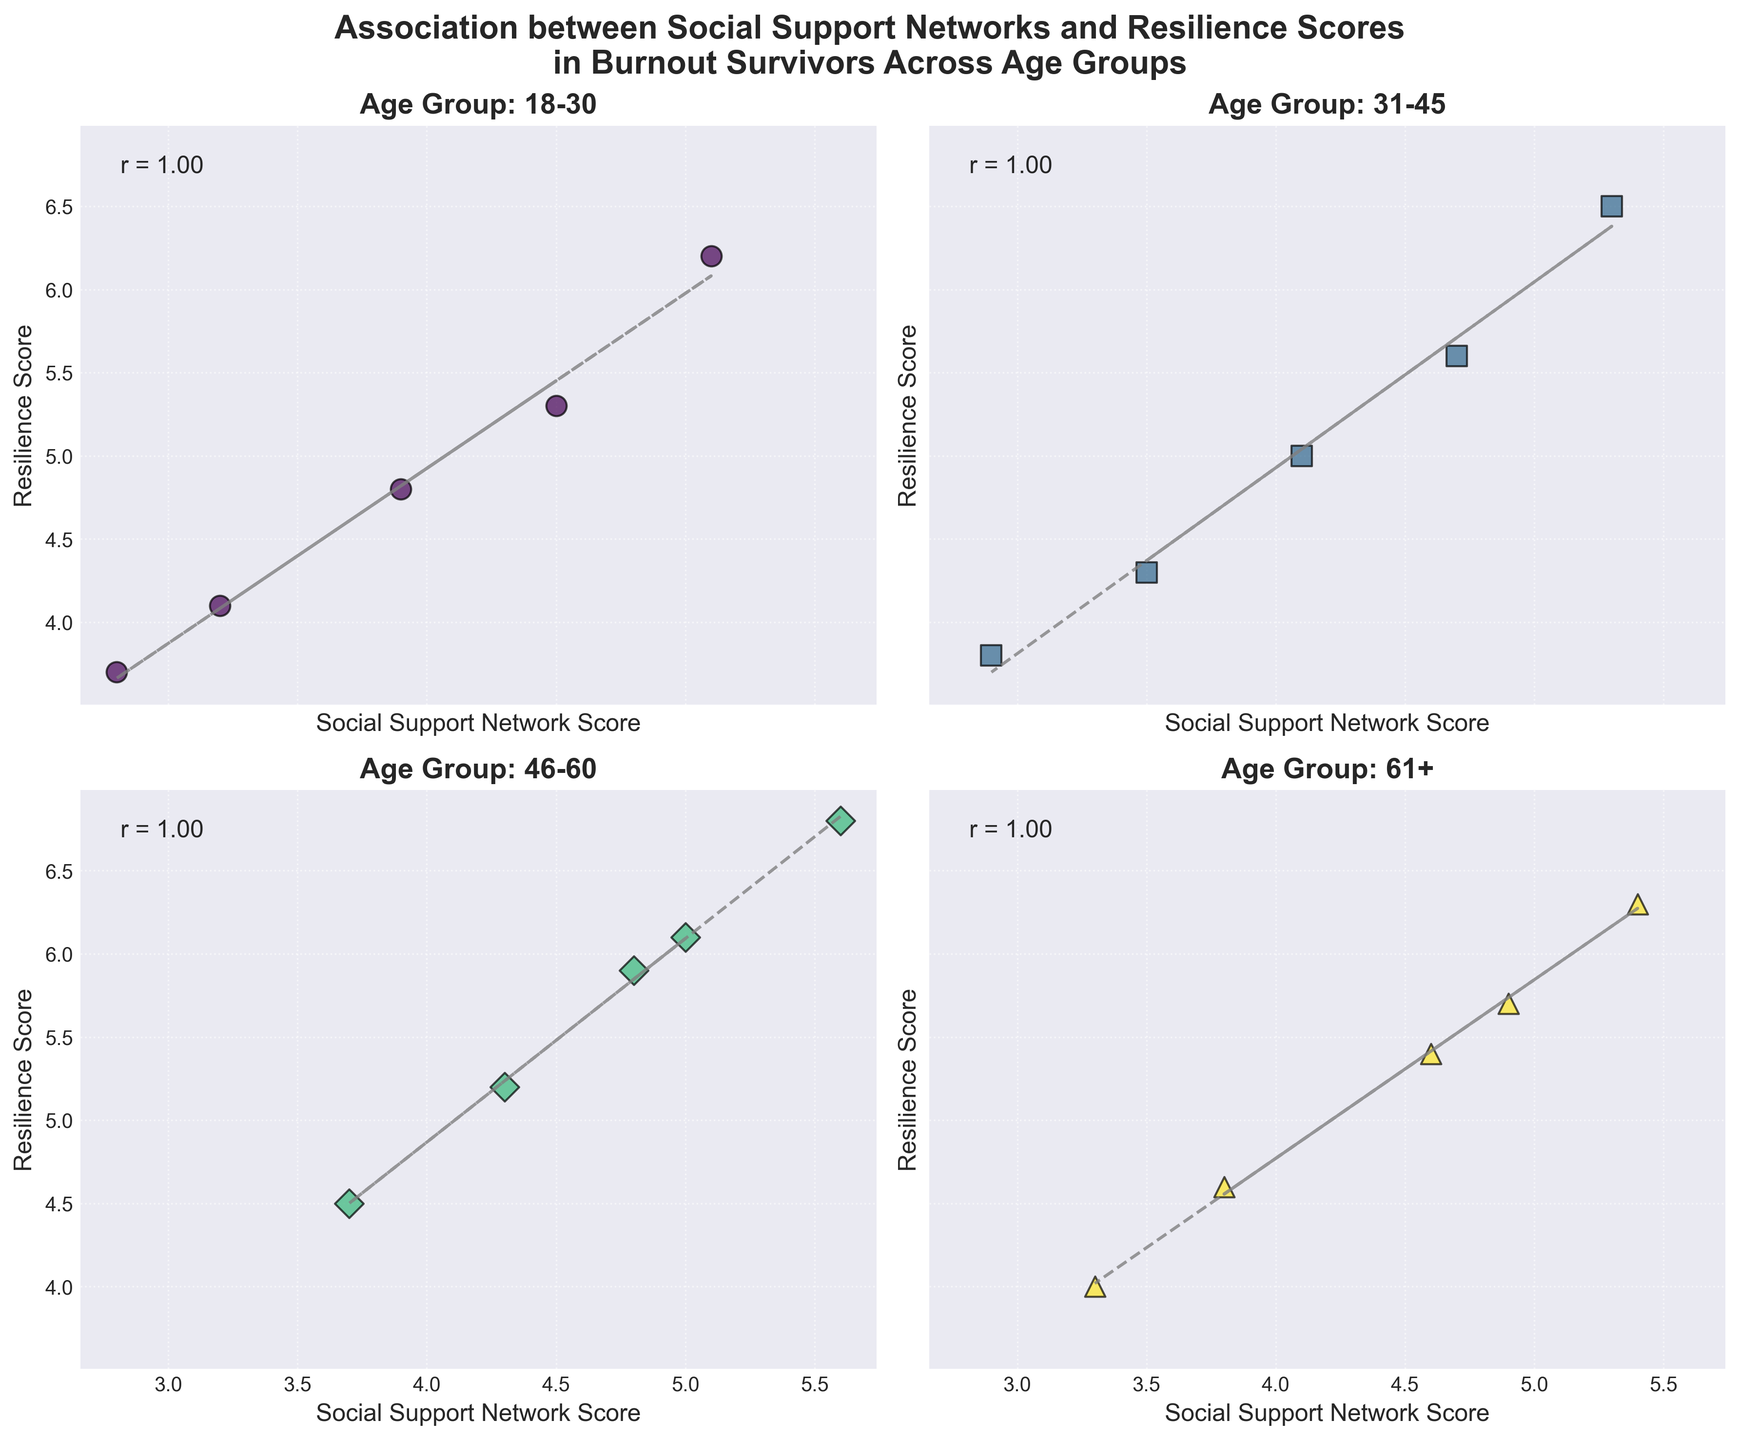Which age group is shown in the top-left subplot? The top-left subplot is labeled "Age Group: 18-30." The age group is mentioned in the title of the subplot.
Answer: 18-30 How many data points are shown in the subplot for the 46-60 age group? The subplot for the 46-60 age group has five data points. This can be counted by the number of scatter points in the specific subplot.
Answer: 5 What is the range of the Social Support Network Scores displayed? By looking at all subplots combined, the Social Support Network Scores range from 2.8 to 5.6. The minimum and maximum values can be seen across different subplots.
Answer: 2.8 to 5.6 Which age group has the highest correlation coefficient between Social Support Network Scores and Resilience Scores? We can compare the correlation coefficients annotated in each subplot. The age group 46-60 has the highest correlation coefficient (r = 0.98).
Answer: 46-60 Do any of the subplots show a negative correlation? All the correlation coefficients annotated in each subplot are positive; therefore, no subplot shows a negative correlation.
Answer: No What is the slope of the linear regression line in the 31-45 age group subplot? The linear regression line in the 31-45 age group subplot has a slope of approximately 1.0. This represents the rate of change in Resilience Score concerning Social Support Network Score.
Answer: 1.0 Which age group shows the least variability in Resilience Scores? Resilience Scores in the 61+ age group show the least variability, as the data points are closely clustered compared to other subplots.
Answer: 61+ How does the Resilience Score change with increasing Social Support Network Score in the 18-30 age group? In the 18-30 age group, the Resilience Score increases with increasing Social Support Network Score, as shown by the positive slope of the regression line.
Answer: Increases Which subgroup has a correclation coefficient closest to 0.8? The subgroup aged 31-45 has the correlation coefficient closest to 0.8, which is r = 0.85 in the plot.
Answer: 31-45 Does the 61+ age group have outliers in Resilience Scores based on the plot? The data points in the 61+ age group are relatively close together, indicating no significant outliers.
Answer: No 